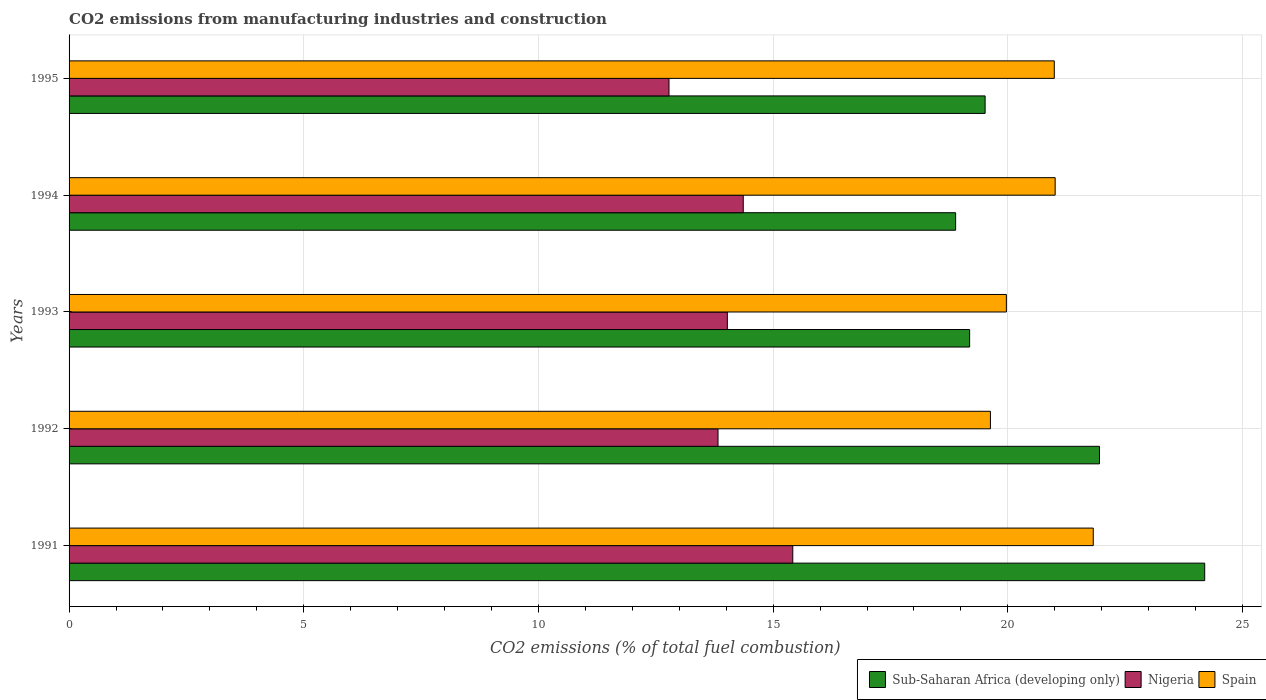How many groups of bars are there?
Provide a succinct answer. 5. Are the number of bars per tick equal to the number of legend labels?
Provide a succinct answer. Yes. Are the number of bars on each tick of the Y-axis equal?
Give a very brief answer. Yes. How many bars are there on the 2nd tick from the top?
Keep it short and to the point. 3. How many bars are there on the 1st tick from the bottom?
Provide a short and direct response. 3. What is the label of the 5th group of bars from the top?
Make the answer very short. 1991. What is the amount of CO2 emitted in Sub-Saharan Africa (developing only) in 1993?
Make the answer very short. 19.19. Across all years, what is the maximum amount of CO2 emitted in Nigeria?
Offer a very short reply. 15.42. Across all years, what is the minimum amount of CO2 emitted in Nigeria?
Ensure brevity in your answer.  12.78. In which year was the amount of CO2 emitted in Nigeria minimum?
Your response must be concise. 1995. What is the total amount of CO2 emitted in Nigeria in the graph?
Your response must be concise. 70.41. What is the difference between the amount of CO2 emitted in Sub-Saharan Africa (developing only) in 1992 and that in 1994?
Your answer should be compact. 3.07. What is the difference between the amount of CO2 emitted in Sub-Saharan Africa (developing only) in 1993 and the amount of CO2 emitted in Nigeria in 1992?
Provide a succinct answer. 5.36. What is the average amount of CO2 emitted in Nigeria per year?
Ensure brevity in your answer.  14.08. In the year 1992, what is the difference between the amount of CO2 emitted in Spain and amount of CO2 emitted in Nigeria?
Your answer should be compact. 5.8. What is the ratio of the amount of CO2 emitted in Sub-Saharan Africa (developing only) in 1993 to that in 1994?
Your answer should be compact. 1.02. Is the difference between the amount of CO2 emitted in Spain in 1992 and 1993 greater than the difference between the amount of CO2 emitted in Nigeria in 1992 and 1993?
Offer a terse response. No. What is the difference between the highest and the second highest amount of CO2 emitted in Spain?
Your response must be concise. 0.81. What is the difference between the highest and the lowest amount of CO2 emitted in Sub-Saharan Africa (developing only)?
Ensure brevity in your answer.  5.31. What does the 2nd bar from the bottom in 1994 represents?
Provide a short and direct response. Nigeria. How many bars are there?
Offer a terse response. 15. How many years are there in the graph?
Provide a short and direct response. 5. Does the graph contain grids?
Provide a short and direct response. Yes. How many legend labels are there?
Your answer should be very brief. 3. What is the title of the graph?
Keep it short and to the point. CO2 emissions from manufacturing industries and construction. Does "Argentina" appear as one of the legend labels in the graph?
Keep it short and to the point. No. What is the label or title of the X-axis?
Provide a short and direct response. CO2 emissions (% of total fuel combustion). What is the label or title of the Y-axis?
Your response must be concise. Years. What is the CO2 emissions (% of total fuel combustion) in Sub-Saharan Africa (developing only) in 1991?
Provide a short and direct response. 24.19. What is the CO2 emissions (% of total fuel combustion) of Nigeria in 1991?
Your answer should be compact. 15.42. What is the CO2 emissions (% of total fuel combustion) of Spain in 1991?
Make the answer very short. 21.82. What is the CO2 emissions (% of total fuel combustion) in Sub-Saharan Africa (developing only) in 1992?
Provide a succinct answer. 21.95. What is the CO2 emissions (% of total fuel combustion) of Nigeria in 1992?
Provide a short and direct response. 13.83. What is the CO2 emissions (% of total fuel combustion) of Spain in 1992?
Offer a very short reply. 19.63. What is the CO2 emissions (% of total fuel combustion) of Sub-Saharan Africa (developing only) in 1993?
Offer a terse response. 19.19. What is the CO2 emissions (% of total fuel combustion) in Nigeria in 1993?
Keep it short and to the point. 14.02. What is the CO2 emissions (% of total fuel combustion) in Spain in 1993?
Your answer should be very brief. 19.97. What is the CO2 emissions (% of total fuel combustion) of Sub-Saharan Africa (developing only) in 1994?
Provide a short and direct response. 18.89. What is the CO2 emissions (% of total fuel combustion) in Nigeria in 1994?
Offer a terse response. 14.36. What is the CO2 emissions (% of total fuel combustion) of Spain in 1994?
Offer a terse response. 21.01. What is the CO2 emissions (% of total fuel combustion) of Sub-Saharan Africa (developing only) in 1995?
Ensure brevity in your answer.  19.52. What is the CO2 emissions (% of total fuel combustion) in Nigeria in 1995?
Make the answer very short. 12.78. What is the CO2 emissions (% of total fuel combustion) in Spain in 1995?
Offer a very short reply. 20.99. Across all years, what is the maximum CO2 emissions (% of total fuel combustion) in Sub-Saharan Africa (developing only)?
Provide a short and direct response. 24.19. Across all years, what is the maximum CO2 emissions (% of total fuel combustion) of Nigeria?
Ensure brevity in your answer.  15.42. Across all years, what is the maximum CO2 emissions (% of total fuel combustion) of Spain?
Keep it short and to the point. 21.82. Across all years, what is the minimum CO2 emissions (% of total fuel combustion) in Sub-Saharan Africa (developing only)?
Your answer should be compact. 18.89. Across all years, what is the minimum CO2 emissions (% of total fuel combustion) of Nigeria?
Provide a short and direct response. 12.78. Across all years, what is the minimum CO2 emissions (% of total fuel combustion) of Spain?
Your answer should be compact. 19.63. What is the total CO2 emissions (% of total fuel combustion) of Sub-Saharan Africa (developing only) in the graph?
Offer a terse response. 103.74. What is the total CO2 emissions (% of total fuel combustion) of Nigeria in the graph?
Your answer should be compact. 70.41. What is the total CO2 emissions (% of total fuel combustion) in Spain in the graph?
Keep it short and to the point. 103.41. What is the difference between the CO2 emissions (% of total fuel combustion) in Sub-Saharan Africa (developing only) in 1991 and that in 1992?
Keep it short and to the point. 2.24. What is the difference between the CO2 emissions (% of total fuel combustion) of Nigeria in 1991 and that in 1992?
Give a very brief answer. 1.59. What is the difference between the CO2 emissions (% of total fuel combustion) in Spain in 1991 and that in 1992?
Your answer should be very brief. 2.19. What is the difference between the CO2 emissions (% of total fuel combustion) in Sub-Saharan Africa (developing only) in 1991 and that in 1993?
Ensure brevity in your answer.  5.01. What is the difference between the CO2 emissions (% of total fuel combustion) of Nigeria in 1991 and that in 1993?
Ensure brevity in your answer.  1.39. What is the difference between the CO2 emissions (% of total fuel combustion) in Spain in 1991 and that in 1993?
Provide a short and direct response. 1.85. What is the difference between the CO2 emissions (% of total fuel combustion) in Sub-Saharan Africa (developing only) in 1991 and that in 1994?
Offer a terse response. 5.31. What is the difference between the CO2 emissions (% of total fuel combustion) of Nigeria in 1991 and that in 1994?
Provide a succinct answer. 1.06. What is the difference between the CO2 emissions (% of total fuel combustion) of Spain in 1991 and that in 1994?
Provide a short and direct response. 0.81. What is the difference between the CO2 emissions (% of total fuel combustion) of Sub-Saharan Africa (developing only) in 1991 and that in 1995?
Give a very brief answer. 4.68. What is the difference between the CO2 emissions (% of total fuel combustion) in Nigeria in 1991 and that in 1995?
Provide a short and direct response. 2.64. What is the difference between the CO2 emissions (% of total fuel combustion) of Spain in 1991 and that in 1995?
Offer a very short reply. 0.83. What is the difference between the CO2 emissions (% of total fuel combustion) in Sub-Saharan Africa (developing only) in 1992 and that in 1993?
Provide a short and direct response. 2.77. What is the difference between the CO2 emissions (% of total fuel combustion) of Nigeria in 1992 and that in 1993?
Give a very brief answer. -0.2. What is the difference between the CO2 emissions (% of total fuel combustion) of Spain in 1992 and that in 1993?
Ensure brevity in your answer.  -0.34. What is the difference between the CO2 emissions (% of total fuel combustion) of Sub-Saharan Africa (developing only) in 1992 and that in 1994?
Ensure brevity in your answer.  3.07. What is the difference between the CO2 emissions (% of total fuel combustion) in Nigeria in 1992 and that in 1994?
Your answer should be very brief. -0.54. What is the difference between the CO2 emissions (% of total fuel combustion) in Spain in 1992 and that in 1994?
Give a very brief answer. -1.38. What is the difference between the CO2 emissions (% of total fuel combustion) of Sub-Saharan Africa (developing only) in 1992 and that in 1995?
Offer a terse response. 2.44. What is the difference between the CO2 emissions (% of total fuel combustion) in Nigeria in 1992 and that in 1995?
Keep it short and to the point. 1.04. What is the difference between the CO2 emissions (% of total fuel combustion) of Spain in 1992 and that in 1995?
Ensure brevity in your answer.  -1.36. What is the difference between the CO2 emissions (% of total fuel combustion) of Sub-Saharan Africa (developing only) in 1993 and that in 1994?
Provide a short and direct response. 0.3. What is the difference between the CO2 emissions (% of total fuel combustion) in Nigeria in 1993 and that in 1994?
Make the answer very short. -0.34. What is the difference between the CO2 emissions (% of total fuel combustion) in Spain in 1993 and that in 1994?
Give a very brief answer. -1.04. What is the difference between the CO2 emissions (% of total fuel combustion) of Sub-Saharan Africa (developing only) in 1993 and that in 1995?
Keep it short and to the point. -0.33. What is the difference between the CO2 emissions (% of total fuel combustion) of Nigeria in 1993 and that in 1995?
Offer a very short reply. 1.24. What is the difference between the CO2 emissions (% of total fuel combustion) in Spain in 1993 and that in 1995?
Keep it short and to the point. -1.02. What is the difference between the CO2 emissions (% of total fuel combustion) of Sub-Saharan Africa (developing only) in 1994 and that in 1995?
Ensure brevity in your answer.  -0.63. What is the difference between the CO2 emissions (% of total fuel combustion) in Nigeria in 1994 and that in 1995?
Provide a short and direct response. 1.58. What is the difference between the CO2 emissions (% of total fuel combustion) of Spain in 1994 and that in 1995?
Provide a succinct answer. 0.02. What is the difference between the CO2 emissions (% of total fuel combustion) of Sub-Saharan Africa (developing only) in 1991 and the CO2 emissions (% of total fuel combustion) of Nigeria in 1992?
Provide a short and direct response. 10.37. What is the difference between the CO2 emissions (% of total fuel combustion) in Sub-Saharan Africa (developing only) in 1991 and the CO2 emissions (% of total fuel combustion) in Spain in 1992?
Ensure brevity in your answer.  4.56. What is the difference between the CO2 emissions (% of total fuel combustion) of Nigeria in 1991 and the CO2 emissions (% of total fuel combustion) of Spain in 1992?
Your answer should be very brief. -4.21. What is the difference between the CO2 emissions (% of total fuel combustion) of Sub-Saharan Africa (developing only) in 1991 and the CO2 emissions (% of total fuel combustion) of Nigeria in 1993?
Provide a succinct answer. 10.17. What is the difference between the CO2 emissions (% of total fuel combustion) in Sub-Saharan Africa (developing only) in 1991 and the CO2 emissions (% of total fuel combustion) in Spain in 1993?
Offer a terse response. 4.23. What is the difference between the CO2 emissions (% of total fuel combustion) of Nigeria in 1991 and the CO2 emissions (% of total fuel combustion) of Spain in 1993?
Provide a succinct answer. -4.55. What is the difference between the CO2 emissions (% of total fuel combustion) in Sub-Saharan Africa (developing only) in 1991 and the CO2 emissions (% of total fuel combustion) in Nigeria in 1994?
Keep it short and to the point. 9.83. What is the difference between the CO2 emissions (% of total fuel combustion) of Sub-Saharan Africa (developing only) in 1991 and the CO2 emissions (% of total fuel combustion) of Spain in 1994?
Keep it short and to the point. 3.19. What is the difference between the CO2 emissions (% of total fuel combustion) in Nigeria in 1991 and the CO2 emissions (% of total fuel combustion) in Spain in 1994?
Offer a terse response. -5.59. What is the difference between the CO2 emissions (% of total fuel combustion) in Sub-Saharan Africa (developing only) in 1991 and the CO2 emissions (% of total fuel combustion) in Nigeria in 1995?
Provide a short and direct response. 11.41. What is the difference between the CO2 emissions (% of total fuel combustion) in Sub-Saharan Africa (developing only) in 1991 and the CO2 emissions (% of total fuel combustion) in Spain in 1995?
Your answer should be compact. 3.2. What is the difference between the CO2 emissions (% of total fuel combustion) of Nigeria in 1991 and the CO2 emissions (% of total fuel combustion) of Spain in 1995?
Your answer should be very brief. -5.57. What is the difference between the CO2 emissions (% of total fuel combustion) in Sub-Saharan Africa (developing only) in 1992 and the CO2 emissions (% of total fuel combustion) in Nigeria in 1993?
Provide a succinct answer. 7.93. What is the difference between the CO2 emissions (% of total fuel combustion) in Sub-Saharan Africa (developing only) in 1992 and the CO2 emissions (% of total fuel combustion) in Spain in 1993?
Make the answer very short. 1.98. What is the difference between the CO2 emissions (% of total fuel combustion) of Nigeria in 1992 and the CO2 emissions (% of total fuel combustion) of Spain in 1993?
Your answer should be compact. -6.14. What is the difference between the CO2 emissions (% of total fuel combustion) of Sub-Saharan Africa (developing only) in 1992 and the CO2 emissions (% of total fuel combustion) of Nigeria in 1994?
Provide a succinct answer. 7.59. What is the difference between the CO2 emissions (% of total fuel combustion) in Sub-Saharan Africa (developing only) in 1992 and the CO2 emissions (% of total fuel combustion) in Spain in 1994?
Your response must be concise. 0.94. What is the difference between the CO2 emissions (% of total fuel combustion) of Nigeria in 1992 and the CO2 emissions (% of total fuel combustion) of Spain in 1994?
Provide a succinct answer. -7.18. What is the difference between the CO2 emissions (% of total fuel combustion) in Sub-Saharan Africa (developing only) in 1992 and the CO2 emissions (% of total fuel combustion) in Nigeria in 1995?
Your response must be concise. 9.17. What is the difference between the CO2 emissions (% of total fuel combustion) in Sub-Saharan Africa (developing only) in 1992 and the CO2 emissions (% of total fuel combustion) in Spain in 1995?
Offer a very short reply. 0.96. What is the difference between the CO2 emissions (% of total fuel combustion) of Nigeria in 1992 and the CO2 emissions (% of total fuel combustion) of Spain in 1995?
Give a very brief answer. -7.16. What is the difference between the CO2 emissions (% of total fuel combustion) of Sub-Saharan Africa (developing only) in 1993 and the CO2 emissions (% of total fuel combustion) of Nigeria in 1994?
Ensure brevity in your answer.  4.82. What is the difference between the CO2 emissions (% of total fuel combustion) in Sub-Saharan Africa (developing only) in 1993 and the CO2 emissions (% of total fuel combustion) in Spain in 1994?
Offer a terse response. -1.82. What is the difference between the CO2 emissions (% of total fuel combustion) of Nigeria in 1993 and the CO2 emissions (% of total fuel combustion) of Spain in 1994?
Ensure brevity in your answer.  -6.98. What is the difference between the CO2 emissions (% of total fuel combustion) of Sub-Saharan Africa (developing only) in 1993 and the CO2 emissions (% of total fuel combustion) of Nigeria in 1995?
Your answer should be compact. 6.4. What is the difference between the CO2 emissions (% of total fuel combustion) in Sub-Saharan Africa (developing only) in 1993 and the CO2 emissions (% of total fuel combustion) in Spain in 1995?
Your answer should be very brief. -1.8. What is the difference between the CO2 emissions (% of total fuel combustion) of Nigeria in 1993 and the CO2 emissions (% of total fuel combustion) of Spain in 1995?
Offer a very short reply. -6.97. What is the difference between the CO2 emissions (% of total fuel combustion) of Sub-Saharan Africa (developing only) in 1994 and the CO2 emissions (% of total fuel combustion) of Nigeria in 1995?
Your response must be concise. 6.11. What is the difference between the CO2 emissions (% of total fuel combustion) in Sub-Saharan Africa (developing only) in 1994 and the CO2 emissions (% of total fuel combustion) in Spain in 1995?
Provide a succinct answer. -2.1. What is the difference between the CO2 emissions (% of total fuel combustion) of Nigeria in 1994 and the CO2 emissions (% of total fuel combustion) of Spain in 1995?
Your response must be concise. -6.63. What is the average CO2 emissions (% of total fuel combustion) of Sub-Saharan Africa (developing only) per year?
Your answer should be compact. 20.75. What is the average CO2 emissions (% of total fuel combustion) of Nigeria per year?
Your answer should be very brief. 14.08. What is the average CO2 emissions (% of total fuel combustion) of Spain per year?
Provide a succinct answer. 20.68. In the year 1991, what is the difference between the CO2 emissions (% of total fuel combustion) in Sub-Saharan Africa (developing only) and CO2 emissions (% of total fuel combustion) in Nigeria?
Offer a terse response. 8.78. In the year 1991, what is the difference between the CO2 emissions (% of total fuel combustion) in Sub-Saharan Africa (developing only) and CO2 emissions (% of total fuel combustion) in Spain?
Ensure brevity in your answer.  2.37. In the year 1991, what is the difference between the CO2 emissions (% of total fuel combustion) in Nigeria and CO2 emissions (% of total fuel combustion) in Spain?
Ensure brevity in your answer.  -6.4. In the year 1992, what is the difference between the CO2 emissions (% of total fuel combustion) of Sub-Saharan Africa (developing only) and CO2 emissions (% of total fuel combustion) of Nigeria?
Ensure brevity in your answer.  8.13. In the year 1992, what is the difference between the CO2 emissions (% of total fuel combustion) of Sub-Saharan Africa (developing only) and CO2 emissions (% of total fuel combustion) of Spain?
Offer a terse response. 2.32. In the year 1992, what is the difference between the CO2 emissions (% of total fuel combustion) in Nigeria and CO2 emissions (% of total fuel combustion) in Spain?
Provide a short and direct response. -5.8. In the year 1993, what is the difference between the CO2 emissions (% of total fuel combustion) of Sub-Saharan Africa (developing only) and CO2 emissions (% of total fuel combustion) of Nigeria?
Your response must be concise. 5.16. In the year 1993, what is the difference between the CO2 emissions (% of total fuel combustion) in Sub-Saharan Africa (developing only) and CO2 emissions (% of total fuel combustion) in Spain?
Provide a succinct answer. -0.78. In the year 1993, what is the difference between the CO2 emissions (% of total fuel combustion) of Nigeria and CO2 emissions (% of total fuel combustion) of Spain?
Your response must be concise. -5.94. In the year 1994, what is the difference between the CO2 emissions (% of total fuel combustion) in Sub-Saharan Africa (developing only) and CO2 emissions (% of total fuel combustion) in Nigeria?
Your response must be concise. 4.52. In the year 1994, what is the difference between the CO2 emissions (% of total fuel combustion) in Sub-Saharan Africa (developing only) and CO2 emissions (% of total fuel combustion) in Spain?
Ensure brevity in your answer.  -2.12. In the year 1994, what is the difference between the CO2 emissions (% of total fuel combustion) of Nigeria and CO2 emissions (% of total fuel combustion) of Spain?
Make the answer very short. -6.64. In the year 1995, what is the difference between the CO2 emissions (% of total fuel combustion) of Sub-Saharan Africa (developing only) and CO2 emissions (% of total fuel combustion) of Nigeria?
Keep it short and to the point. 6.73. In the year 1995, what is the difference between the CO2 emissions (% of total fuel combustion) in Sub-Saharan Africa (developing only) and CO2 emissions (% of total fuel combustion) in Spain?
Offer a terse response. -1.47. In the year 1995, what is the difference between the CO2 emissions (% of total fuel combustion) in Nigeria and CO2 emissions (% of total fuel combustion) in Spain?
Give a very brief answer. -8.21. What is the ratio of the CO2 emissions (% of total fuel combustion) in Sub-Saharan Africa (developing only) in 1991 to that in 1992?
Provide a succinct answer. 1.1. What is the ratio of the CO2 emissions (% of total fuel combustion) of Nigeria in 1991 to that in 1992?
Give a very brief answer. 1.12. What is the ratio of the CO2 emissions (% of total fuel combustion) of Spain in 1991 to that in 1992?
Your response must be concise. 1.11. What is the ratio of the CO2 emissions (% of total fuel combustion) of Sub-Saharan Africa (developing only) in 1991 to that in 1993?
Your answer should be compact. 1.26. What is the ratio of the CO2 emissions (% of total fuel combustion) of Nigeria in 1991 to that in 1993?
Provide a succinct answer. 1.1. What is the ratio of the CO2 emissions (% of total fuel combustion) of Spain in 1991 to that in 1993?
Your answer should be very brief. 1.09. What is the ratio of the CO2 emissions (% of total fuel combustion) in Sub-Saharan Africa (developing only) in 1991 to that in 1994?
Your answer should be very brief. 1.28. What is the ratio of the CO2 emissions (% of total fuel combustion) of Nigeria in 1991 to that in 1994?
Make the answer very short. 1.07. What is the ratio of the CO2 emissions (% of total fuel combustion) of Spain in 1991 to that in 1994?
Make the answer very short. 1.04. What is the ratio of the CO2 emissions (% of total fuel combustion) in Sub-Saharan Africa (developing only) in 1991 to that in 1995?
Make the answer very short. 1.24. What is the ratio of the CO2 emissions (% of total fuel combustion) in Nigeria in 1991 to that in 1995?
Offer a terse response. 1.21. What is the ratio of the CO2 emissions (% of total fuel combustion) of Spain in 1991 to that in 1995?
Offer a very short reply. 1.04. What is the ratio of the CO2 emissions (% of total fuel combustion) of Sub-Saharan Africa (developing only) in 1992 to that in 1993?
Provide a succinct answer. 1.14. What is the ratio of the CO2 emissions (% of total fuel combustion) of Nigeria in 1992 to that in 1993?
Your answer should be compact. 0.99. What is the ratio of the CO2 emissions (% of total fuel combustion) of Sub-Saharan Africa (developing only) in 1992 to that in 1994?
Your response must be concise. 1.16. What is the ratio of the CO2 emissions (% of total fuel combustion) in Nigeria in 1992 to that in 1994?
Offer a terse response. 0.96. What is the ratio of the CO2 emissions (% of total fuel combustion) in Spain in 1992 to that in 1994?
Offer a terse response. 0.93. What is the ratio of the CO2 emissions (% of total fuel combustion) of Sub-Saharan Africa (developing only) in 1992 to that in 1995?
Keep it short and to the point. 1.12. What is the ratio of the CO2 emissions (% of total fuel combustion) in Nigeria in 1992 to that in 1995?
Your answer should be very brief. 1.08. What is the ratio of the CO2 emissions (% of total fuel combustion) of Spain in 1992 to that in 1995?
Make the answer very short. 0.94. What is the ratio of the CO2 emissions (% of total fuel combustion) in Sub-Saharan Africa (developing only) in 1993 to that in 1994?
Give a very brief answer. 1.02. What is the ratio of the CO2 emissions (% of total fuel combustion) in Nigeria in 1993 to that in 1994?
Provide a succinct answer. 0.98. What is the ratio of the CO2 emissions (% of total fuel combustion) of Spain in 1993 to that in 1994?
Your response must be concise. 0.95. What is the ratio of the CO2 emissions (% of total fuel combustion) in Sub-Saharan Africa (developing only) in 1993 to that in 1995?
Your answer should be very brief. 0.98. What is the ratio of the CO2 emissions (% of total fuel combustion) of Nigeria in 1993 to that in 1995?
Give a very brief answer. 1.1. What is the ratio of the CO2 emissions (% of total fuel combustion) of Spain in 1993 to that in 1995?
Your answer should be very brief. 0.95. What is the ratio of the CO2 emissions (% of total fuel combustion) of Sub-Saharan Africa (developing only) in 1994 to that in 1995?
Provide a short and direct response. 0.97. What is the ratio of the CO2 emissions (% of total fuel combustion) in Nigeria in 1994 to that in 1995?
Provide a short and direct response. 1.12. What is the difference between the highest and the second highest CO2 emissions (% of total fuel combustion) in Sub-Saharan Africa (developing only)?
Your answer should be very brief. 2.24. What is the difference between the highest and the second highest CO2 emissions (% of total fuel combustion) of Nigeria?
Your response must be concise. 1.06. What is the difference between the highest and the second highest CO2 emissions (% of total fuel combustion) in Spain?
Offer a terse response. 0.81. What is the difference between the highest and the lowest CO2 emissions (% of total fuel combustion) in Sub-Saharan Africa (developing only)?
Your answer should be very brief. 5.31. What is the difference between the highest and the lowest CO2 emissions (% of total fuel combustion) of Nigeria?
Ensure brevity in your answer.  2.64. What is the difference between the highest and the lowest CO2 emissions (% of total fuel combustion) of Spain?
Keep it short and to the point. 2.19. 